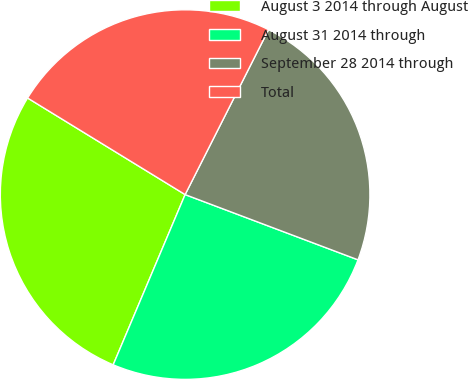<chart> <loc_0><loc_0><loc_500><loc_500><pie_chart><fcel>August 3 2014 through August<fcel>August 31 2014 through<fcel>September 28 2014 through<fcel>Total<nl><fcel>27.39%<fcel>25.62%<fcel>23.29%<fcel>23.7%<nl></chart> 